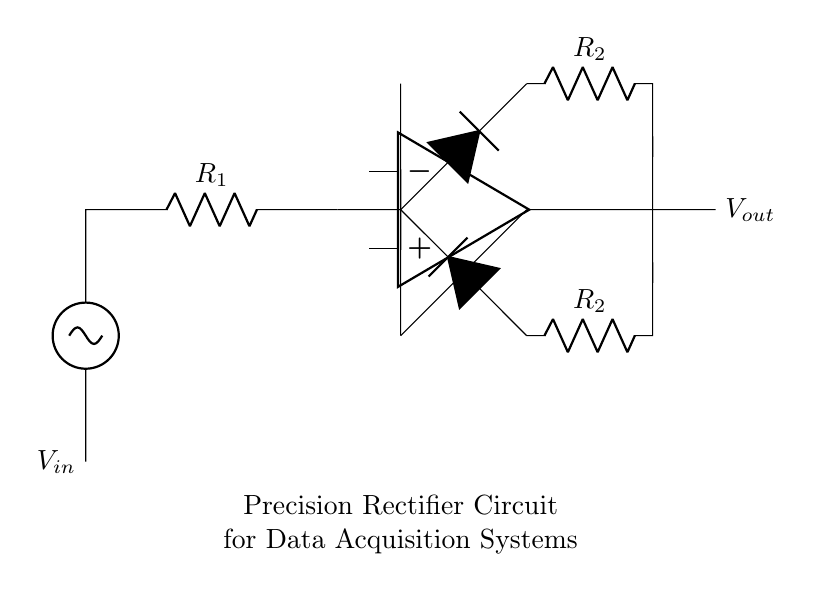What is the function of the op-amp in this circuit? The op-amp acts as a comparator and amplifier, ensuring that the output voltage closely follows the input voltage with minimal distortion.
Answer: Comparator and amplifier What type of diodes are used in the precision rectifier circuit? The circuit uses diodes marked with an asterisk, indicating that they are precision diodes, allowing for accurate rectification of small signals.
Answer: Precision diodes What do the resistors R1 and R2 control in this circuit? The resistors control the gain and feedback in the op-amp configuration, affecting the output voltage and stability of the circuit.
Answer: Gain and feedback What is the expected output when the input voltage is negative? When the input voltage is negative, the precision rectifier circuit will output a zero voltage (or close to it), as the diodes will not conduct in that direction.
Answer: Zero voltage How many resistors are present in the diagram? There are two resistors labeled as R1 and two labeled as R2, totaling four resistors in the circuit.
Answer: Four resistors In which type of systems is this precision rectifier circuit primarily used? This circuit is primarily used in data acquisition systems where accurate conversion of analog signals to digital form is required.
Answer: Data acquisition systems What is the primary advantage of using a precision rectifier over a standard rectifier? A precision rectifier allows for the accurate processing of small amplitude signals that typical rectifiers cannot handle effectively.
Answer: Accurate processing of small signals 